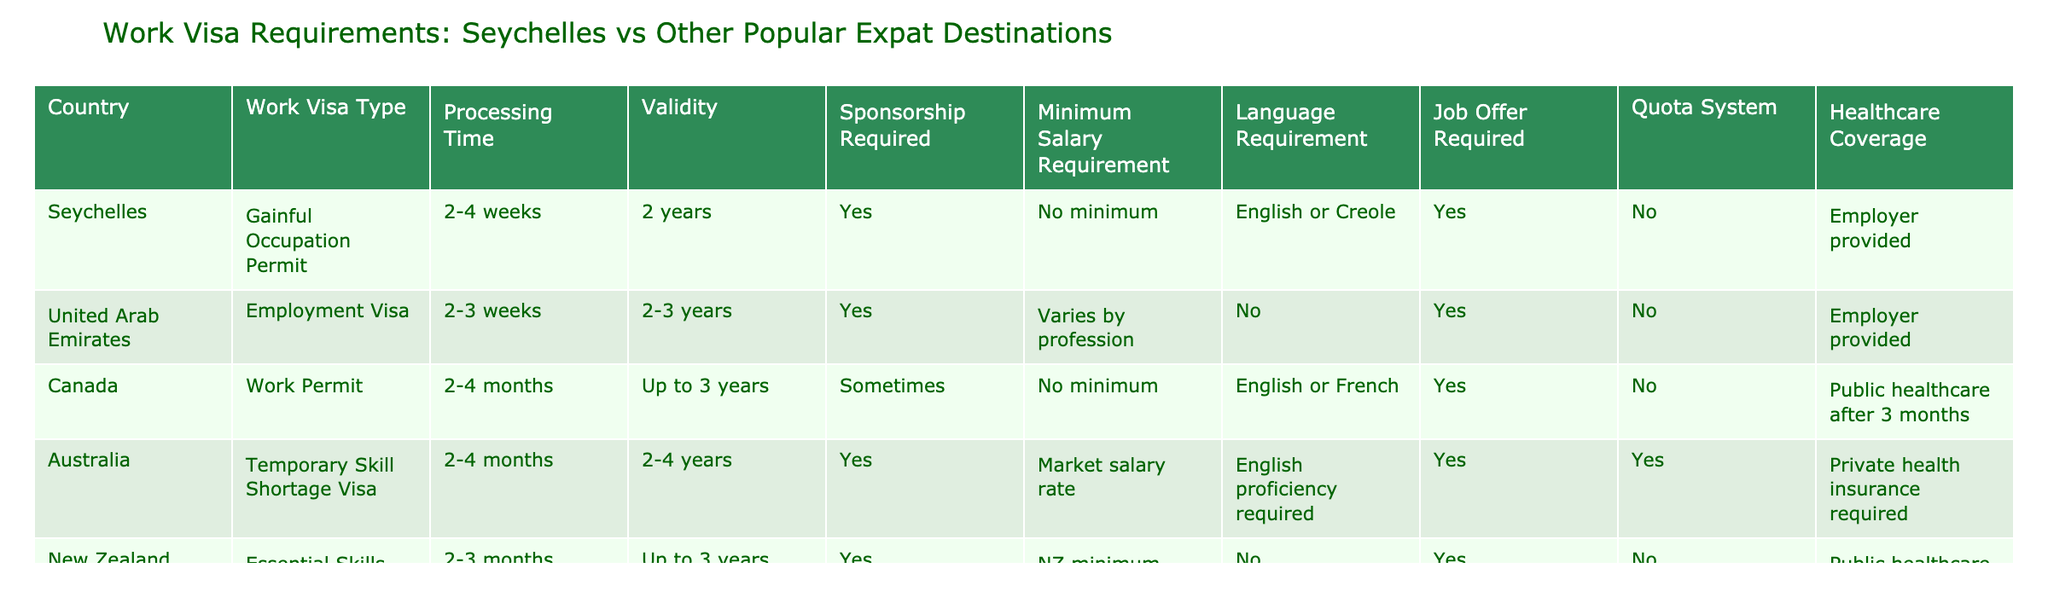What is the processing time for obtaining a Work Permit in Canada? According to the table, the processing time for a Work Permit in Canada is listed as 2-4 months.
Answer: 2-4 months Is a job offer required to apply for a Gainful Occupation Permit in Seychelles? The table shows that a job offer is indeed required to apply for a Gainful Occupation Permit in Seychelles.
Answer: Yes Which country has the longest validity period for its work visa? Looking at the table, Canada offers a Work Permit valid for up to 3 years, while the UAE and Seychelles offer visas of 2-3 years and 2 years respectively. Thus, both Canada and UAE provide longer durations, with Canada being slightly longer at up to 3 years.
Answer: Canada What are the language requirements for the work visa in Australia? The table indicates that the language requirement for the Temporary Skill Shortage Visa in Australia is English proficiency required.
Answer: English proficiency required How many countries require sponsorship for their work visas? When examining the table, we see that Seychelles, UAE, Australia, and New Zealand all require sponsorship for their work visas, while only Canada has a 'sometimes' option. Thus, if we tally the countries as per these conditions, we find four.
Answer: Four countries Is there a minimum salary requirement for the work visa in Seychelles? The data specifies that there is no minimum salary requirement for obtaining a Gainful Occupation Permit in Seychelles.
Answer: No What is the healthcare coverage provision for work visa holders in Canada? According to the information provided in the table, public healthcare is available for visa holders after a waiting period of 3 months in Canada.
Answer: Public healthcare after 3 months Which country requires private health insurance for work visa holders? The table states that Australia requires private health insurance for individuals on a Temporary Skill Shortage Visa.
Answer: Australia Do all listed countries have a quota system in place for work visas? Analyzing the table, it shows that only Australia has a quota system for its work visa, while the others do not; therefore, it is not true that all have a quota system.
Answer: No 